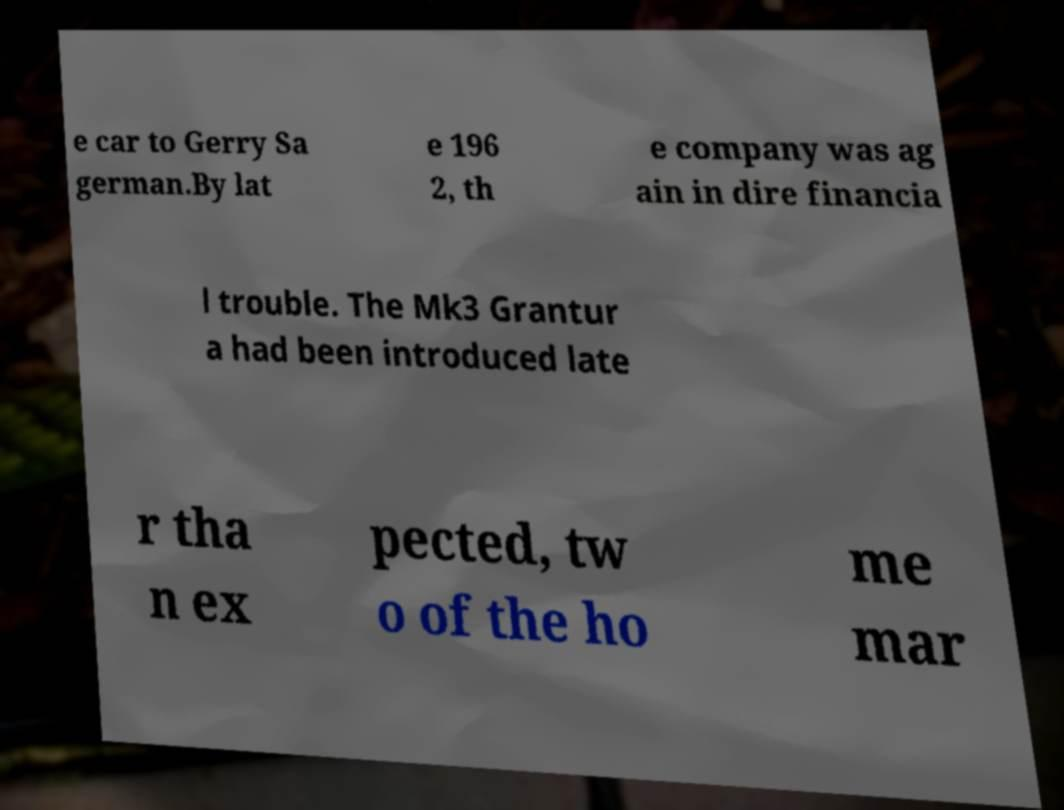Please read and relay the text visible in this image. What does it say? e car to Gerry Sa german.By lat e 196 2, th e company was ag ain in dire financia l trouble. The Mk3 Grantur a had been introduced late r tha n ex pected, tw o of the ho me mar 